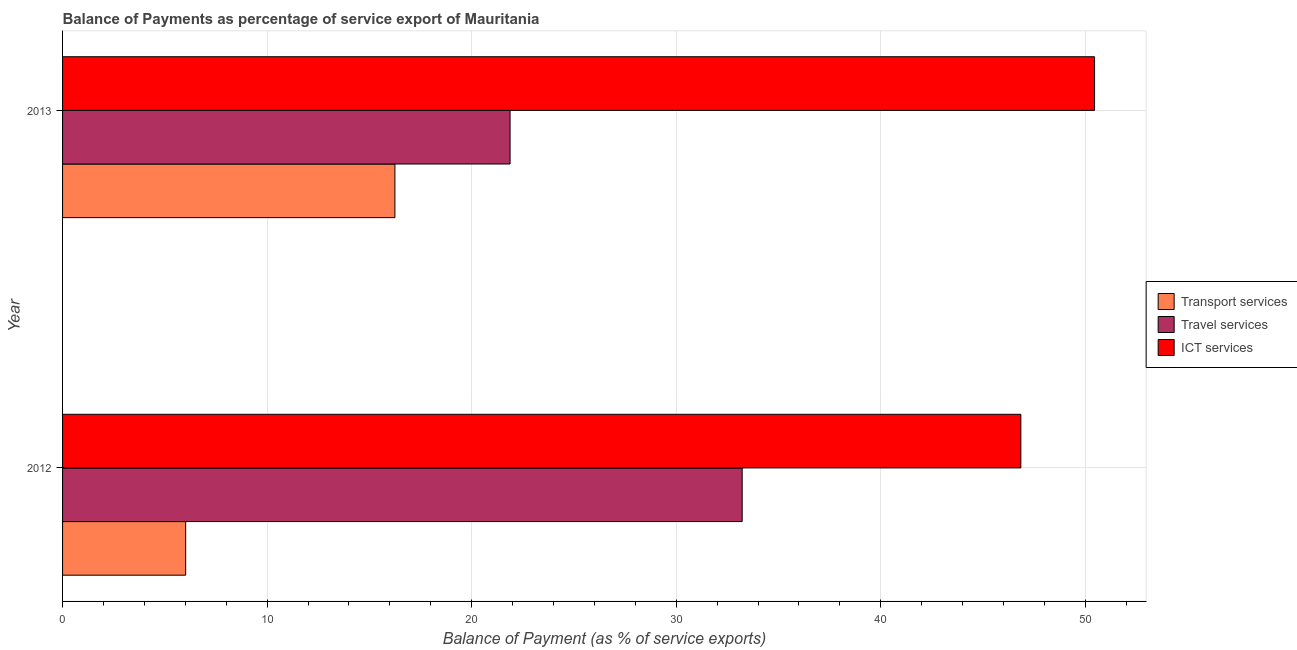How many different coloured bars are there?
Offer a very short reply. 3. How many bars are there on the 2nd tick from the bottom?
Offer a terse response. 3. What is the label of the 1st group of bars from the top?
Your answer should be very brief. 2013. In how many cases, is the number of bars for a given year not equal to the number of legend labels?
Give a very brief answer. 0. What is the balance of payment of transport services in 2013?
Your response must be concise. 16.25. Across all years, what is the maximum balance of payment of ict services?
Offer a terse response. 50.45. Across all years, what is the minimum balance of payment of transport services?
Give a very brief answer. 6.02. In which year was the balance of payment of travel services maximum?
Offer a terse response. 2012. In which year was the balance of payment of transport services minimum?
Your answer should be very brief. 2012. What is the total balance of payment of travel services in the graph?
Your answer should be compact. 55.1. What is the difference between the balance of payment of transport services in 2012 and that in 2013?
Provide a short and direct response. -10.23. What is the difference between the balance of payment of ict services in 2013 and the balance of payment of transport services in 2012?
Provide a succinct answer. 44.43. What is the average balance of payment of transport services per year?
Provide a succinct answer. 11.13. In the year 2012, what is the difference between the balance of payment of travel services and balance of payment of ict services?
Provide a succinct answer. -13.62. What is the ratio of the balance of payment of transport services in 2012 to that in 2013?
Give a very brief answer. 0.37. Is the balance of payment of ict services in 2012 less than that in 2013?
Give a very brief answer. Yes. Is the difference between the balance of payment of travel services in 2012 and 2013 greater than the difference between the balance of payment of ict services in 2012 and 2013?
Give a very brief answer. Yes. What does the 2nd bar from the top in 2013 represents?
Your response must be concise. Travel services. What does the 3rd bar from the bottom in 2013 represents?
Keep it short and to the point. ICT services. How many bars are there?
Your answer should be compact. 6. Are all the bars in the graph horizontal?
Your response must be concise. Yes. How many years are there in the graph?
Keep it short and to the point. 2. Are the values on the major ticks of X-axis written in scientific E-notation?
Make the answer very short. No. Does the graph contain any zero values?
Your response must be concise. No. Where does the legend appear in the graph?
Your answer should be compact. Center right. How many legend labels are there?
Give a very brief answer. 3. How are the legend labels stacked?
Keep it short and to the point. Vertical. What is the title of the graph?
Offer a very short reply. Balance of Payments as percentage of service export of Mauritania. What is the label or title of the X-axis?
Provide a succinct answer. Balance of Payment (as % of service exports). What is the label or title of the Y-axis?
Give a very brief answer. Year. What is the Balance of Payment (as % of service exports) in Transport services in 2012?
Give a very brief answer. 6.02. What is the Balance of Payment (as % of service exports) of Travel services in 2012?
Your answer should be very brief. 33.22. What is the Balance of Payment (as % of service exports) in ICT services in 2012?
Ensure brevity in your answer.  46.85. What is the Balance of Payment (as % of service exports) of Transport services in 2013?
Make the answer very short. 16.25. What is the Balance of Payment (as % of service exports) of Travel services in 2013?
Your response must be concise. 21.88. What is the Balance of Payment (as % of service exports) of ICT services in 2013?
Your answer should be compact. 50.45. Across all years, what is the maximum Balance of Payment (as % of service exports) of Transport services?
Provide a succinct answer. 16.25. Across all years, what is the maximum Balance of Payment (as % of service exports) in Travel services?
Ensure brevity in your answer.  33.22. Across all years, what is the maximum Balance of Payment (as % of service exports) in ICT services?
Your answer should be compact. 50.45. Across all years, what is the minimum Balance of Payment (as % of service exports) of Transport services?
Make the answer very short. 6.02. Across all years, what is the minimum Balance of Payment (as % of service exports) in Travel services?
Provide a short and direct response. 21.88. Across all years, what is the minimum Balance of Payment (as % of service exports) in ICT services?
Your answer should be very brief. 46.85. What is the total Balance of Payment (as % of service exports) in Transport services in the graph?
Keep it short and to the point. 22.27. What is the total Balance of Payment (as % of service exports) of Travel services in the graph?
Offer a terse response. 55.1. What is the total Balance of Payment (as % of service exports) of ICT services in the graph?
Your answer should be compact. 97.3. What is the difference between the Balance of Payment (as % of service exports) of Transport services in 2012 and that in 2013?
Offer a terse response. -10.23. What is the difference between the Balance of Payment (as % of service exports) of Travel services in 2012 and that in 2013?
Give a very brief answer. 11.35. What is the difference between the Balance of Payment (as % of service exports) of ICT services in 2012 and that in 2013?
Your answer should be very brief. -3.6. What is the difference between the Balance of Payment (as % of service exports) of Transport services in 2012 and the Balance of Payment (as % of service exports) of Travel services in 2013?
Offer a very short reply. -15.86. What is the difference between the Balance of Payment (as % of service exports) of Transport services in 2012 and the Balance of Payment (as % of service exports) of ICT services in 2013?
Give a very brief answer. -44.43. What is the difference between the Balance of Payment (as % of service exports) in Travel services in 2012 and the Balance of Payment (as % of service exports) in ICT services in 2013?
Your response must be concise. -17.23. What is the average Balance of Payment (as % of service exports) in Transport services per year?
Give a very brief answer. 11.13. What is the average Balance of Payment (as % of service exports) of Travel services per year?
Make the answer very short. 27.55. What is the average Balance of Payment (as % of service exports) in ICT services per year?
Provide a succinct answer. 48.65. In the year 2012, what is the difference between the Balance of Payment (as % of service exports) of Transport services and Balance of Payment (as % of service exports) of Travel services?
Provide a succinct answer. -27.21. In the year 2012, what is the difference between the Balance of Payment (as % of service exports) in Transport services and Balance of Payment (as % of service exports) in ICT services?
Keep it short and to the point. -40.83. In the year 2012, what is the difference between the Balance of Payment (as % of service exports) in Travel services and Balance of Payment (as % of service exports) in ICT services?
Make the answer very short. -13.62. In the year 2013, what is the difference between the Balance of Payment (as % of service exports) in Transport services and Balance of Payment (as % of service exports) in Travel services?
Keep it short and to the point. -5.63. In the year 2013, what is the difference between the Balance of Payment (as % of service exports) in Transport services and Balance of Payment (as % of service exports) in ICT services?
Make the answer very short. -34.2. In the year 2013, what is the difference between the Balance of Payment (as % of service exports) in Travel services and Balance of Payment (as % of service exports) in ICT services?
Give a very brief answer. -28.57. What is the ratio of the Balance of Payment (as % of service exports) in Transport services in 2012 to that in 2013?
Ensure brevity in your answer.  0.37. What is the ratio of the Balance of Payment (as % of service exports) in Travel services in 2012 to that in 2013?
Provide a succinct answer. 1.52. What is the difference between the highest and the second highest Balance of Payment (as % of service exports) in Transport services?
Offer a very short reply. 10.23. What is the difference between the highest and the second highest Balance of Payment (as % of service exports) of Travel services?
Offer a terse response. 11.35. What is the difference between the highest and the second highest Balance of Payment (as % of service exports) of ICT services?
Ensure brevity in your answer.  3.6. What is the difference between the highest and the lowest Balance of Payment (as % of service exports) of Transport services?
Your response must be concise. 10.23. What is the difference between the highest and the lowest Balance of Payment (as % of service exports) of Travel services?
Your answer should be compact. 11.35. What is the difference between the highest and the lowest Balance of Payment (as % of service exports) in ICT services?
Ensure brevity in your answer.  3.6. 